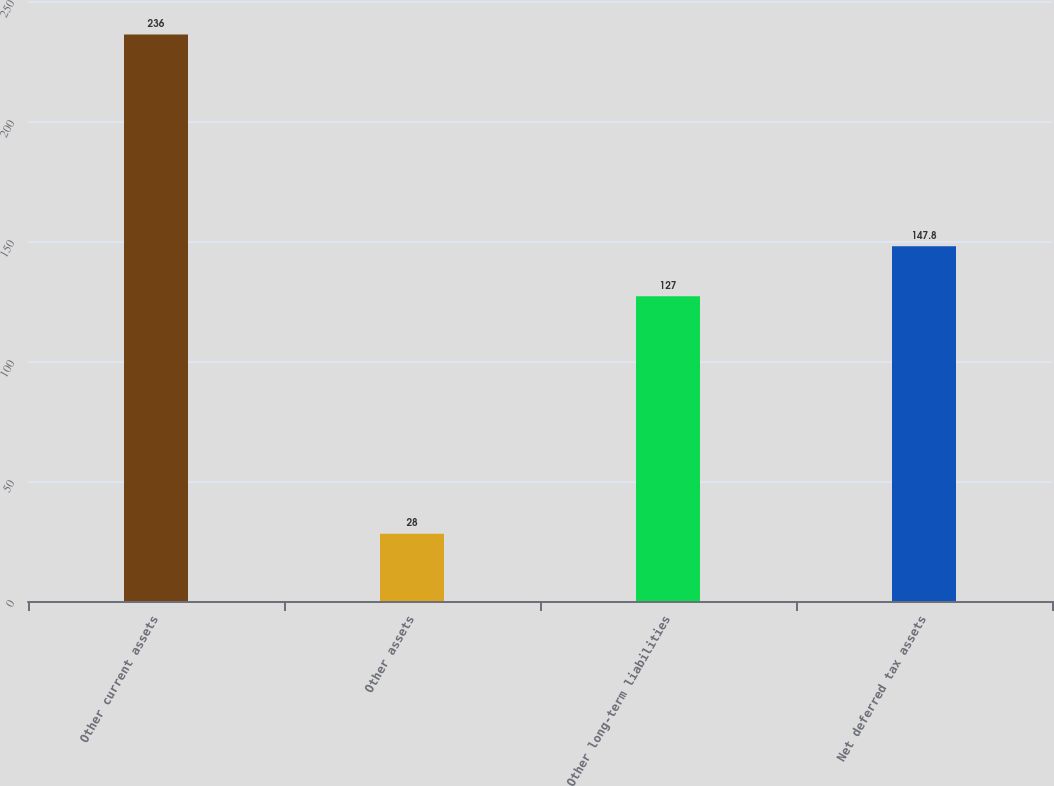Convert chart. <chart><loc_0><loc_0><loc_500><loc_500><bar_chart><fcel>Other current assets<fcel>Other assets<fcel>Other long-term liabilities<fcel>Net deferred tax assets<nl><fcel>236<fcel>28<fcel>127<fcel>147.8<nl></chart> 